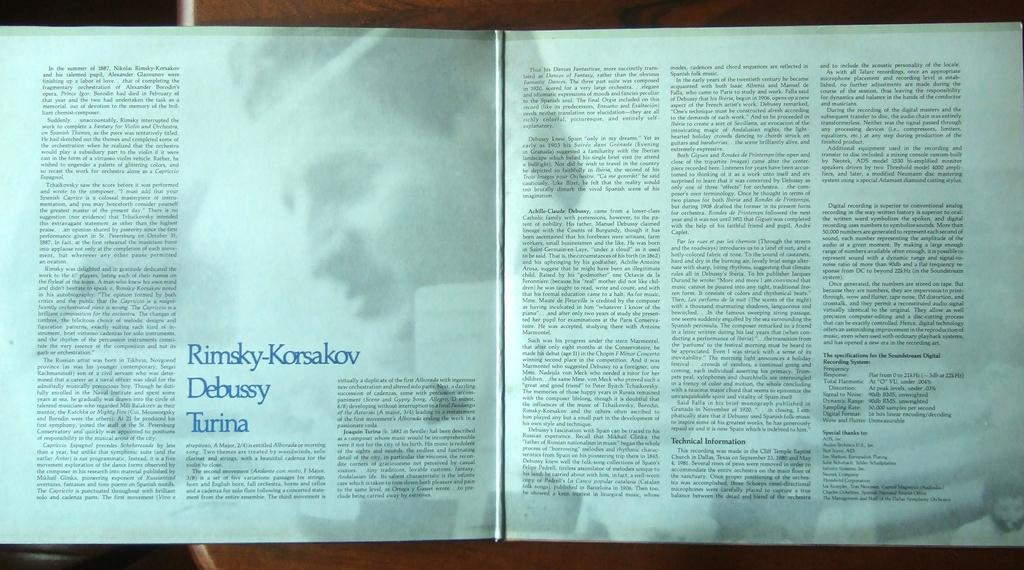<image>
Provide a brief description of the given image. the word debussy that is in a book 